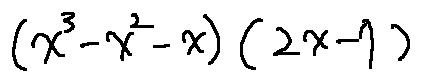Convert formula to latex. <formula><loc_0><loc_0><loc_500><loc_500>( x ^ { 3 } - x ^ { 2 } - x ) ( 2 x - 7 )</formula> 